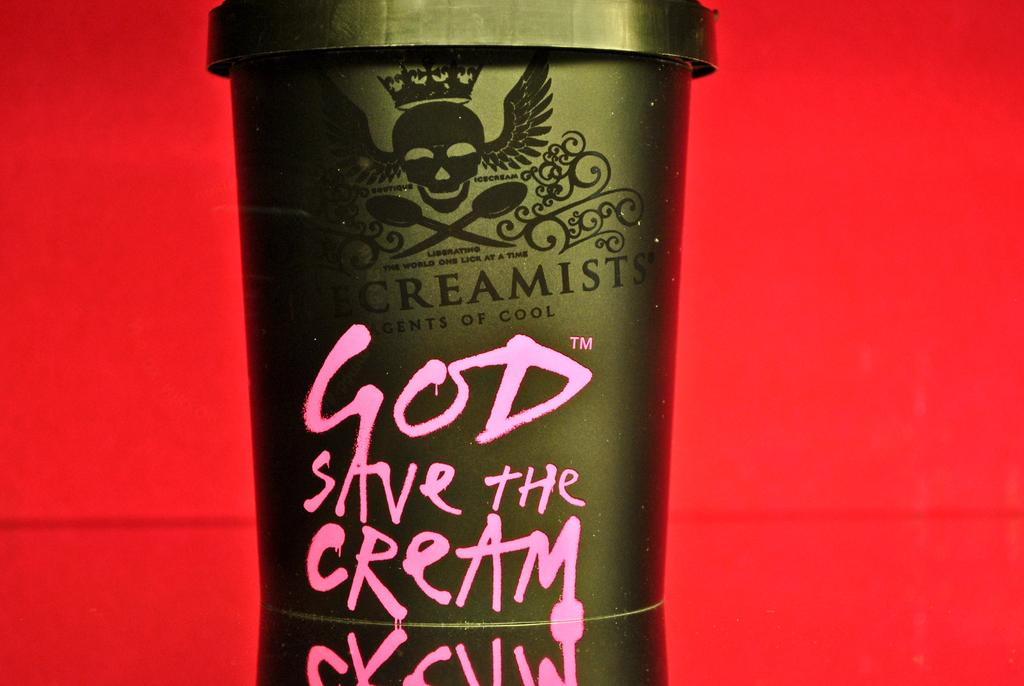Provide a one-sentence caption for the provided image. A close up of a odd looking carton of cream. 